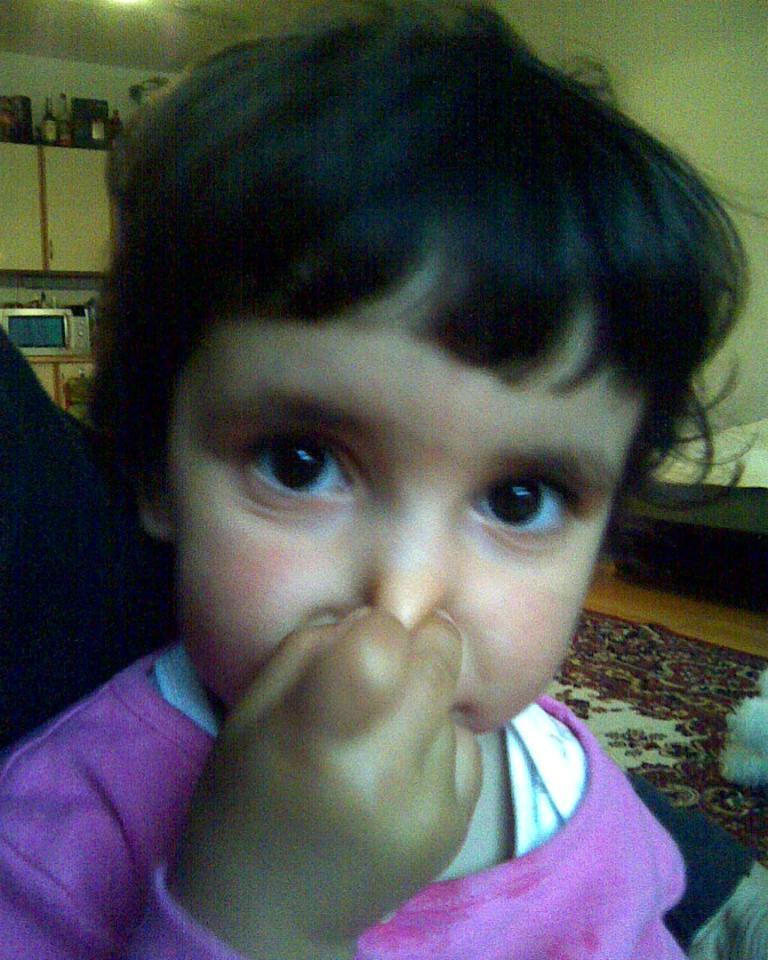Describe this image in one or two sentences. In this image in the foreground we can see a child pressing the nose and the child having black hair. 